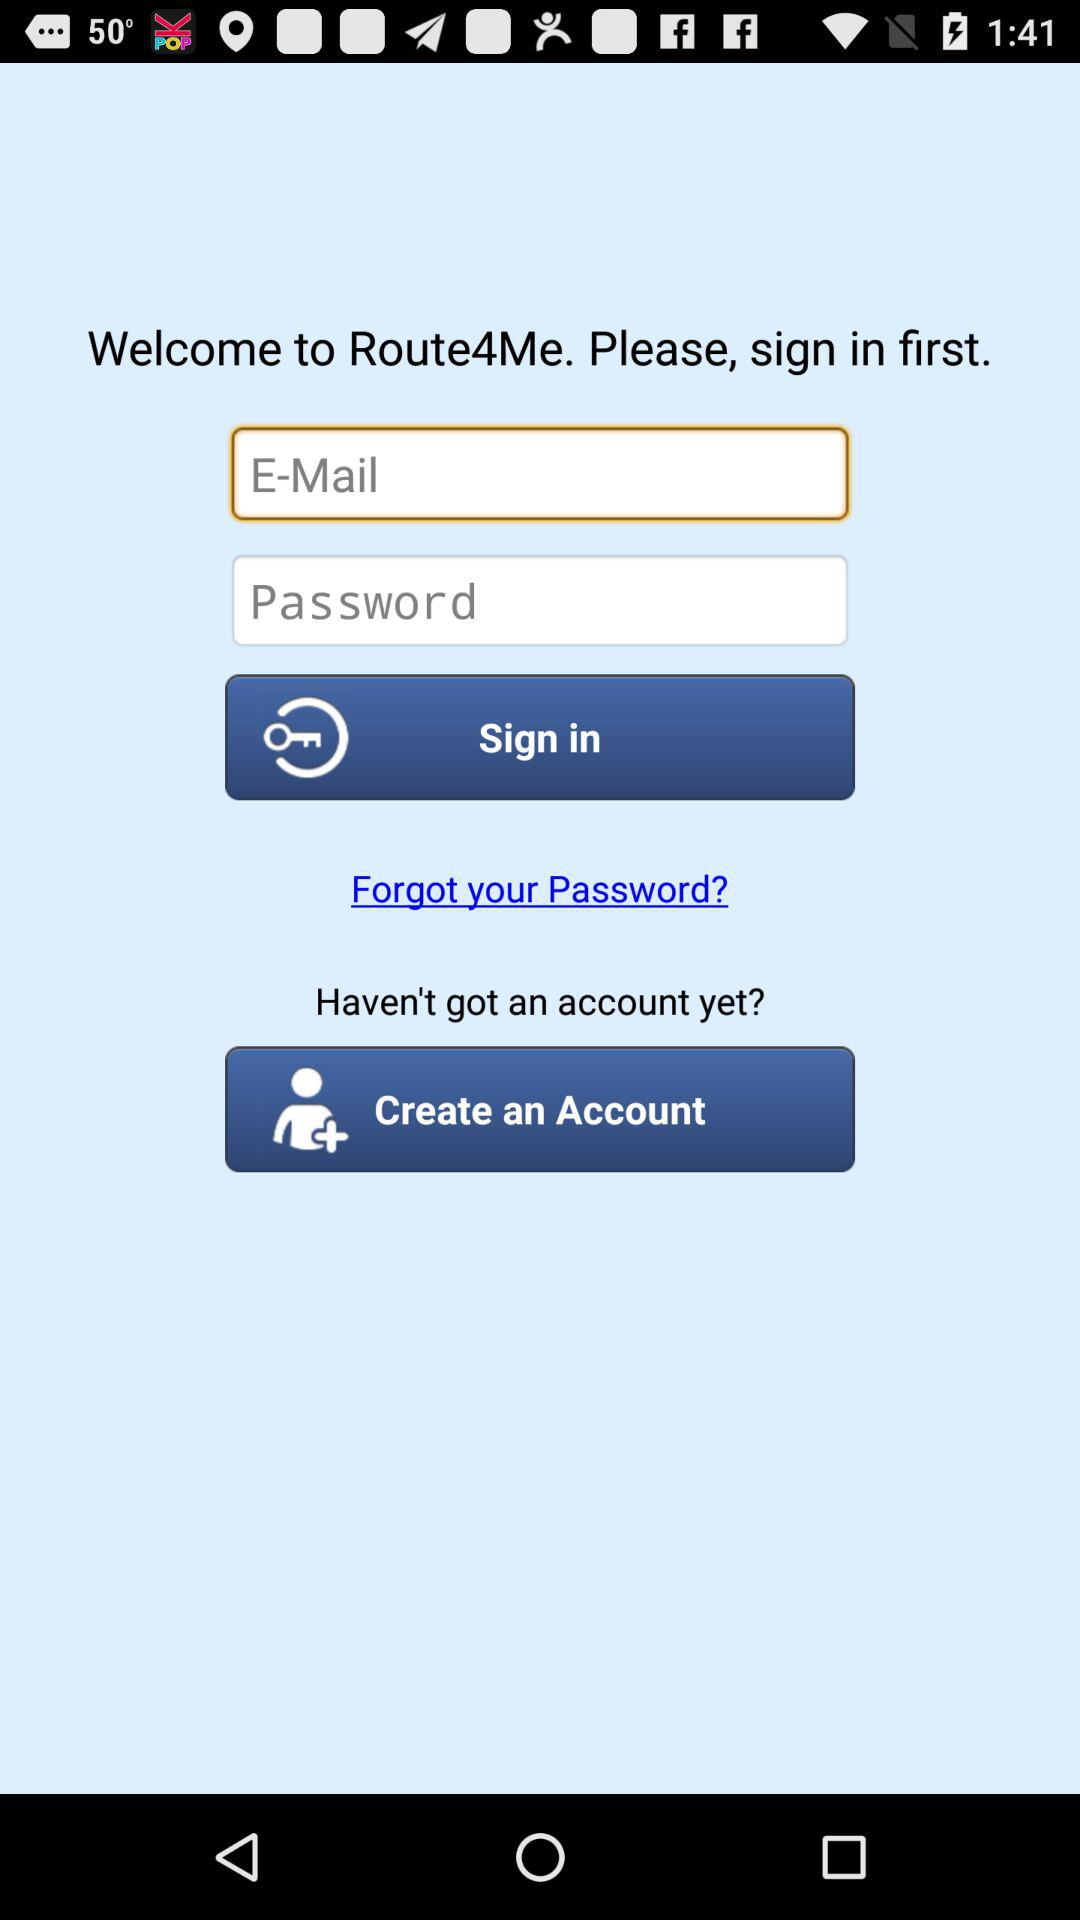What is the application name? The application name is "Route4Me". 